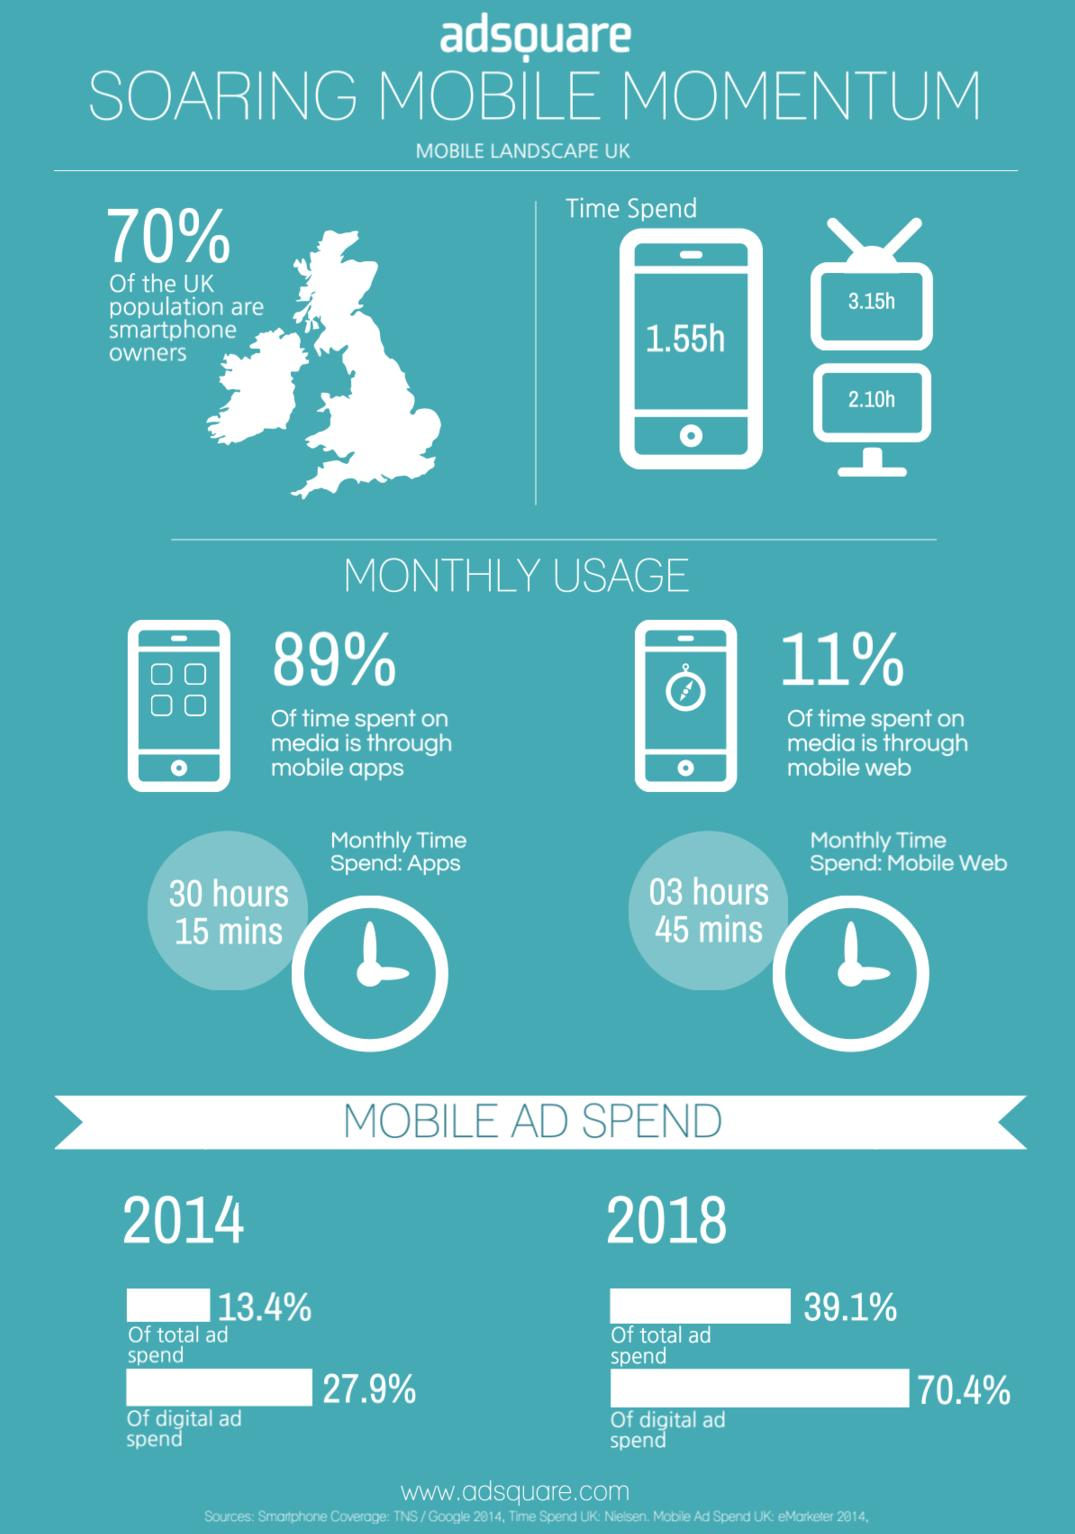Highlight a few significant elements in this photo. According to a recent survey, approximately 30% of the UK population does not own a smartphone. The total time spent by people in the UK on computers is approximately 2.10 hours. In the UK, the average person spends approximately 3.15 hours per day watching television. In the United Kingdom, the average person spends 1.55 hours per day on their smartphone. In the UK, approximately 11% of the time spent on media is through mobile web. 